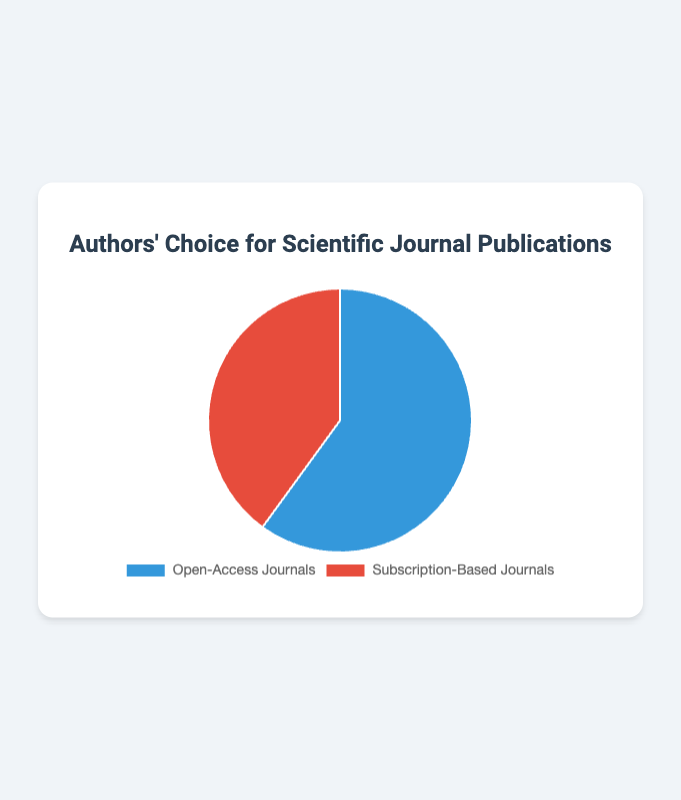What percentage of publications are in open-access journals? According to the pie chart, open-access journals account for 60 out of 100 publications. To find the percentage, divide 60 by the total number of publications (100), then multiply by 100. Thus, (60 / 100) * 100 = 60%.
Answer: 60% What percentage of publications are in subscription-based journals? According to the pie chart, subscription-based journals account for 40 out of 100 publications. To find the percentage, divide 40 by the total number of publications (100), then multiply by 100. Thus, (40 / 100) * 100 = 40%.
Answer: 40% How many more publications are in open-access journals compared to subscription-based journals? According to the chart, there are 60 publications in open-access journals and 40 in subscription-based journals. The difference between them is 60 - 40.
Answer: 20 What is the ratio of open-access to subscription-based journal publications? The number of open-access journal publications is 60 and subscription-based journal publications is 40. The ratio is calculated by dividing 60 by 40, which simplifies to 3:2.
Answer: 3:2 If 20 more publications were made in subscription-based journals, what would be the new percentage of subscription-based journal publications? Initially, there are 40 subscription-based journal publications. Adding 20 more makes it 60. The new total number of publications is 60 (open-access) + 60 (subscription-based) = 120. The percentage is then (60 / 120) * 100 = 50%.
Answer: 50% Which journal type is more popular among authors? Comparing the counts, open-access journals have 60 publications while subscription-based journals have 40. Therefore, open-access journals are more popular.
Answer: Open-access journals What is the total number of publications represented in the chart? To find the total number of publications, sum the quantities for both journal types: 60 (open-access) + 40 (subscription-based) = 100.
Answer: 100 By what factor is the number of open-access journal publications greater than that of subscription-based publications? The number of open-access publications (60) divided by the number of subscription-based publications (40) gives: 60 / 40 = 1.5.
Answer: 1.5 How many publications would each journal type need to achieve an equal distribution between them? To achieve equal distribution, the total number of publications (100) should be equally split. Each journal type would need 100 / 2 = 50 publications. Open-access journals currently have 60, so they need to reduce by 10. Subscription-based journals have 40, so they need to increase by 10.
Answer: Open-access: Reduce by 10; Subscription-based: Increase by 10 